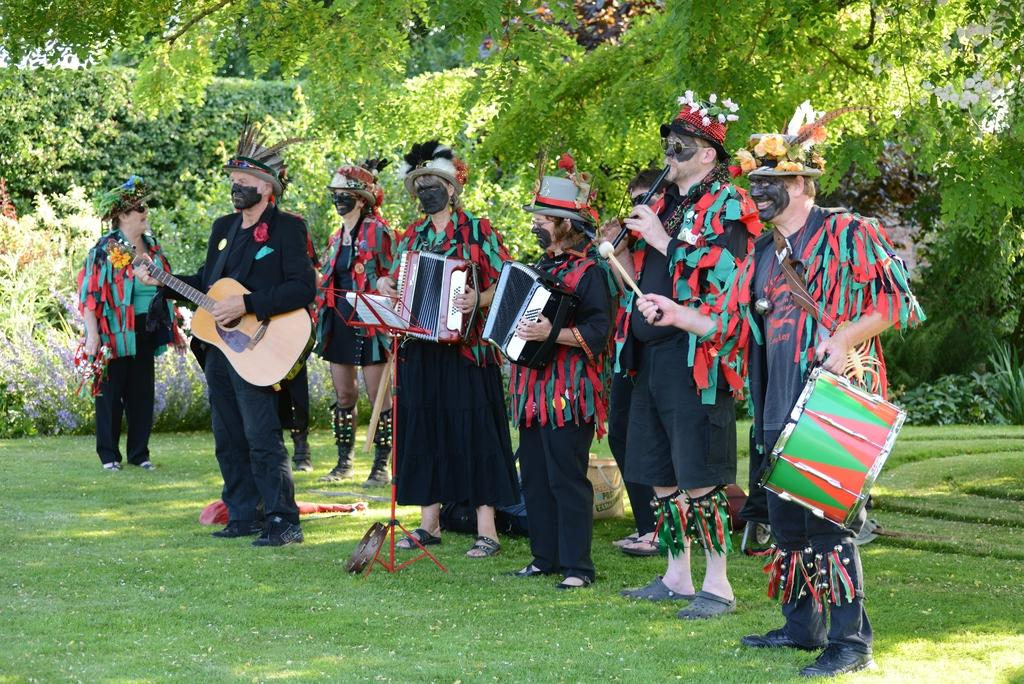What are the people in the image doing? The people in the image are playing musical instruments. What can be seen in the background of the image? There are trees visible in the background of the image. What type of ground is present at the bottom of the image? There is grass at the bottom of the image. What type of waves can be seen crashing on the shore in the image? There are no waves or shore visible in the image; it features people playing musical instruments with trees in the background and grass at the bottom. 